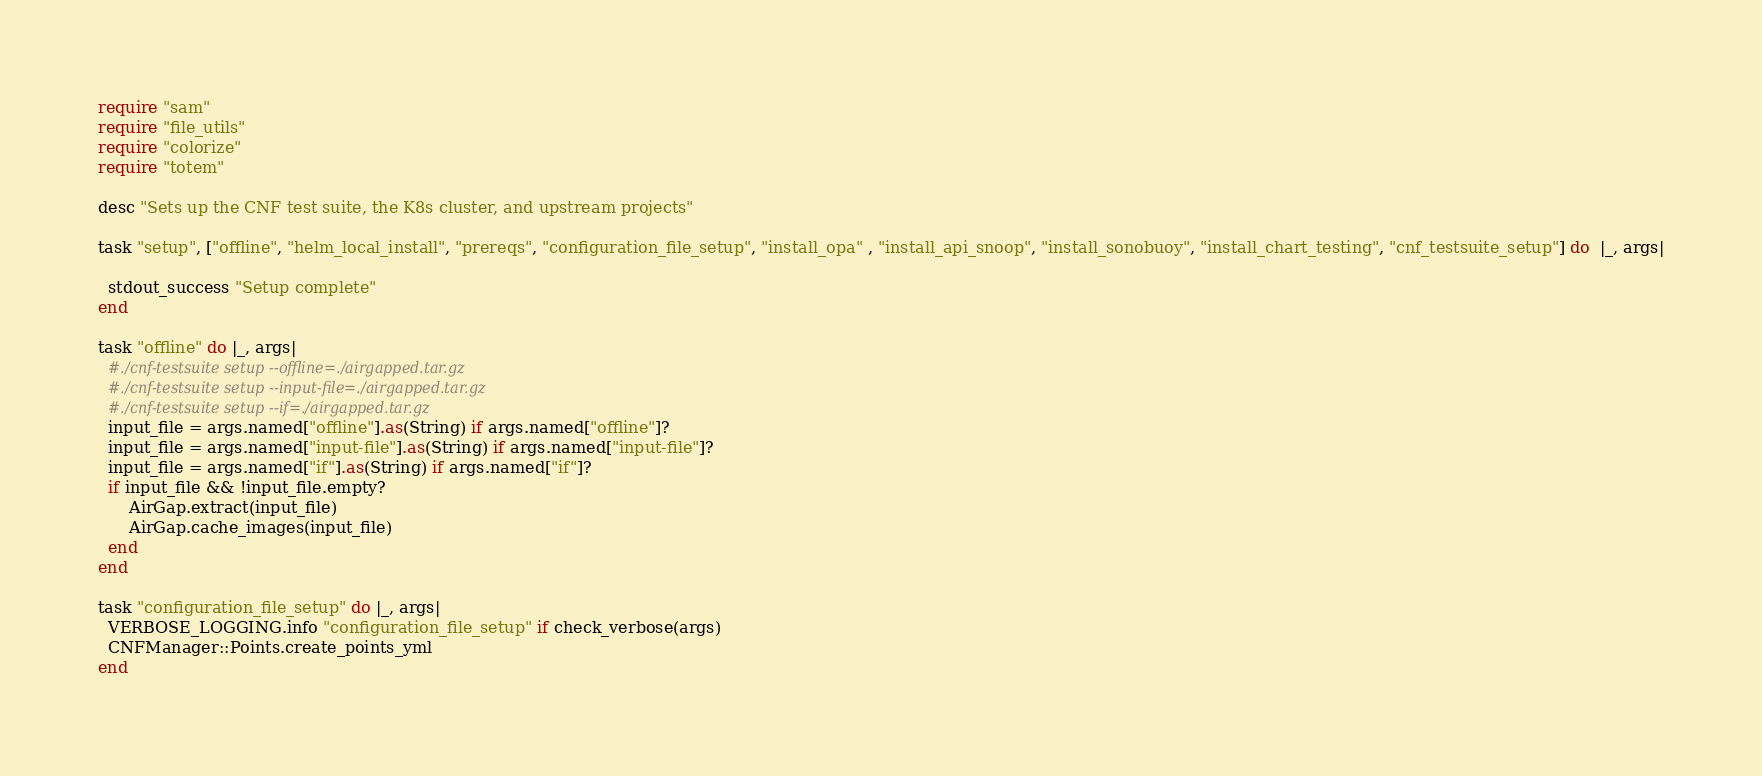<code> <loc_0><loc_0><loc_500><loc_500><_Crystal_>require "sam"
require "file_utils"
require "colorize"
require "totem"

desc "Sets up the CNF test suite, the K8s cluster, and upstream projects"

task "setup", ["offline", "helm_local_install", "prereqs", "configuration_file_setup", "install_opa" , "install_api_snoop", "install_sonobuoy", "install_chart_testing", "cnf_testsuite_setup"] do  |_, args|

  stdout_success "Setup complete"
end

task "offline" do |_, args|
  #./cnf-testsuite setup --offline=./airgapped.tar.gz
  #./cnf-testsuite setup --input-file=./airgapped.tar.gz
  #./cnf-testsuite setup --if=./airgapped.tar.gz
  input_file = args.named["offline"].as(String) if args.named["offline"]?
  input_file = args.named["input-file"].as(String) if args.named["input-file"]?
  input_file = args.named["if"].as(String) if args.named["if"]?
  if input_file && !input_file.empty?
      AirGap.extract(input_file)
      AirGap.cache_images(input_file)
  end
end

task "configuration_file_setup" do |_, args|
  VERBOSE_LOGGING.info "configuration_file_setup" if check_verbose(args)
  CNFManager::Points.create_points_yml
end

</code> 